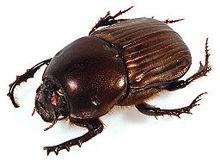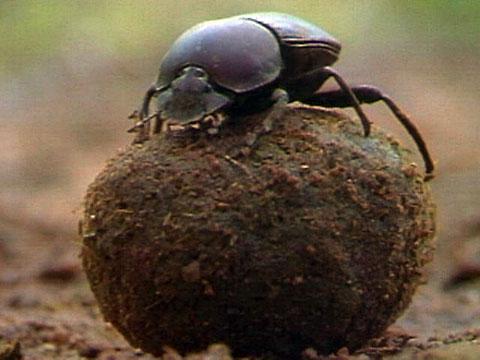The first image is the image on the left, the second image is the image on the right. Examine the images to the left and right. Is the description "Two beetles are near a ball of dirt in one of the images." accurate? Answer yes or no. No. The first image is the image on the left, the second image is the image on the right. Given the left and right images, does the statement "One image does not include a dungball with the beetle." hold true? Answer yes or no. Yes. The first image is the image on the left, the second image is the image on the right. Assess this claim about the two images: "At least one beatle has its hind legs on a ball while its front legs are on the ground.". Correct or not? Answer yes or no. No. The first image is the image on the left, the second image is the image on the right. Considering the images on both sides, is "Left image shows just one beetle, with hind legs on dung ball and front legs on ground." valid? Answer yes or no. No. 